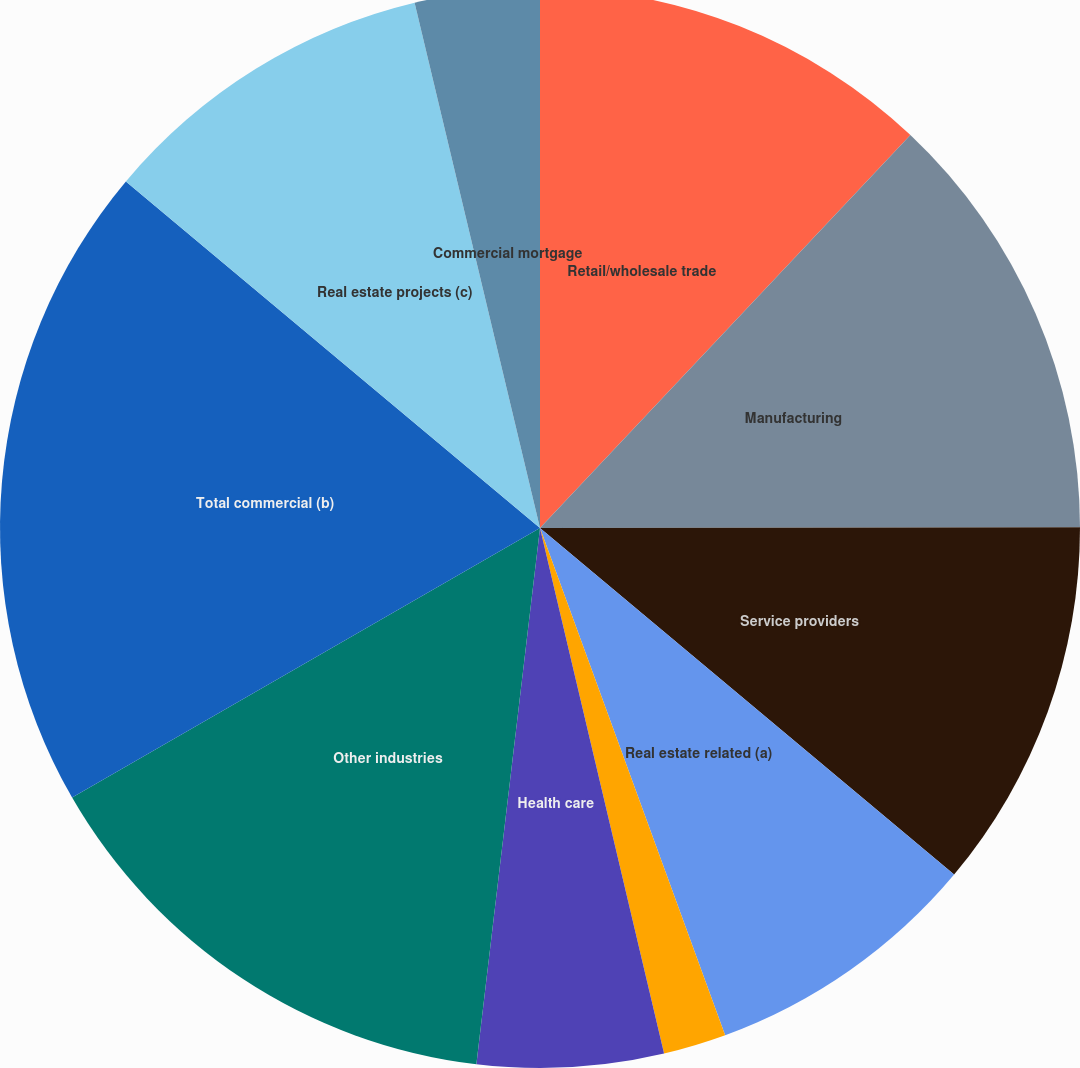<chart> <loc_0><loc_0><loc_500><loc_500><pie_chart><fcel>Retail/wholesale trade<fcel>Manufacturing<fcel>Service providers<fcel>Real estate related (a)<fcel>Financial services<fcel>Health care<fcel>Other industries<fcel>Total commercial (b)<fcel>Real estate projects (c)<fcel>Commercial mortgage<nl><fcel>12.03%<fcel>12.95%<fcel>11.11%<fcel>8.34%<fcel>1.88%<fcel>5.57%<fcel>14.8%<fcel>19.41%<fcel>10.18%<fcel>3.73%<nl></chart> 